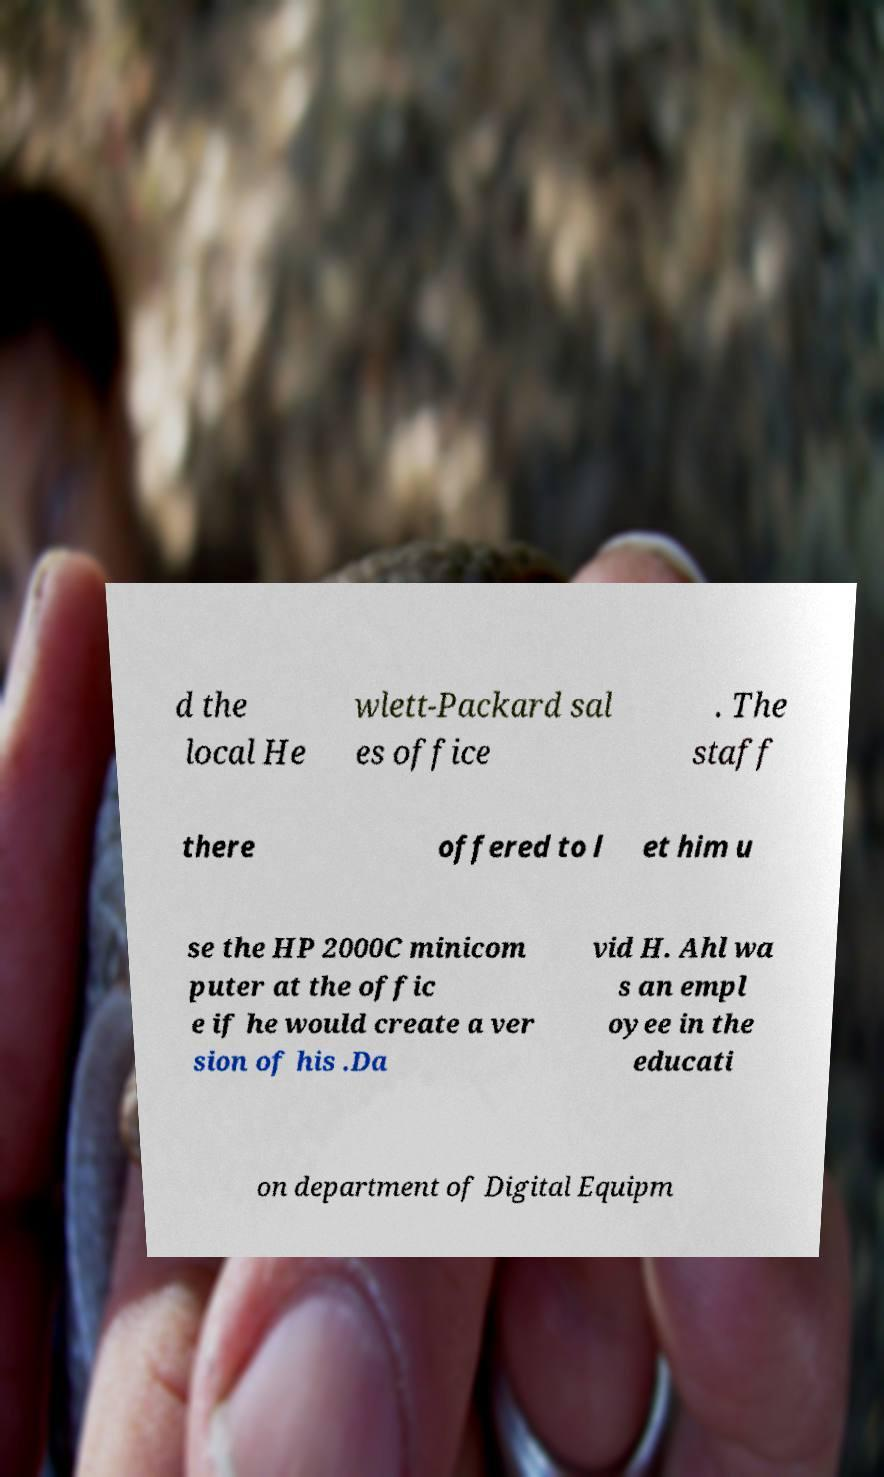I need the written content from this picture converted into text. Can you do that? d the local He wlett-Packard sal es office . The staff there offered to l et him u se the HP 2000C minicom puter at the offic e if he would create a ver sion of his .Da vid H. Ahl wa s an empl oyee in the educati on department of Digital Equipm 